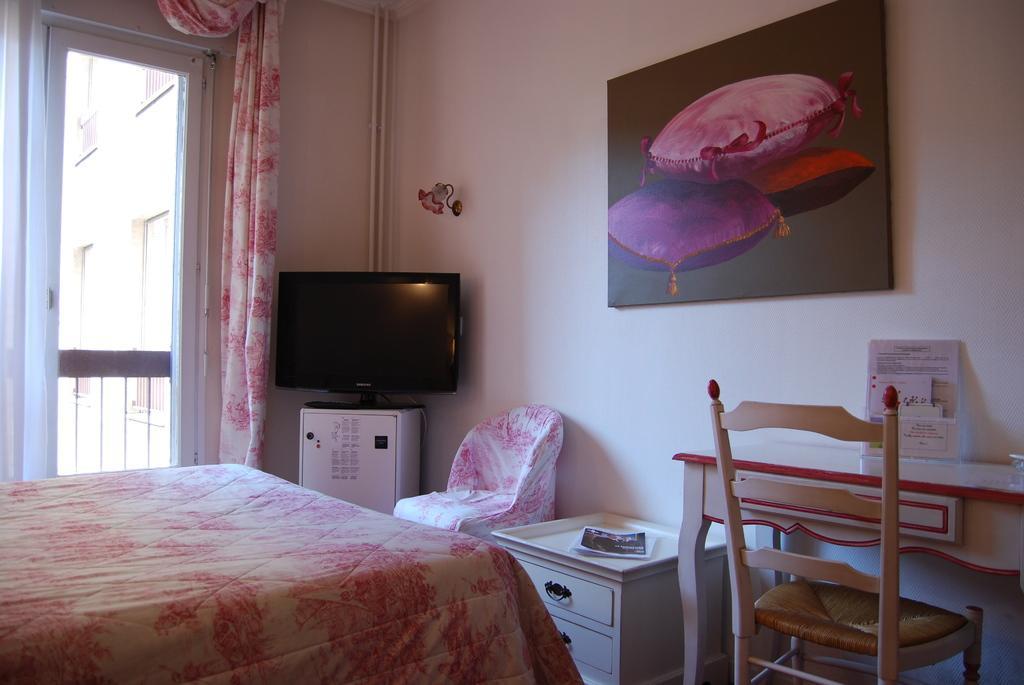Describe this image in one or two sentences. There is a table which is white and pink in color and there is a door beside it and there is a television,chair,table and a picture on the wall in front of it. 